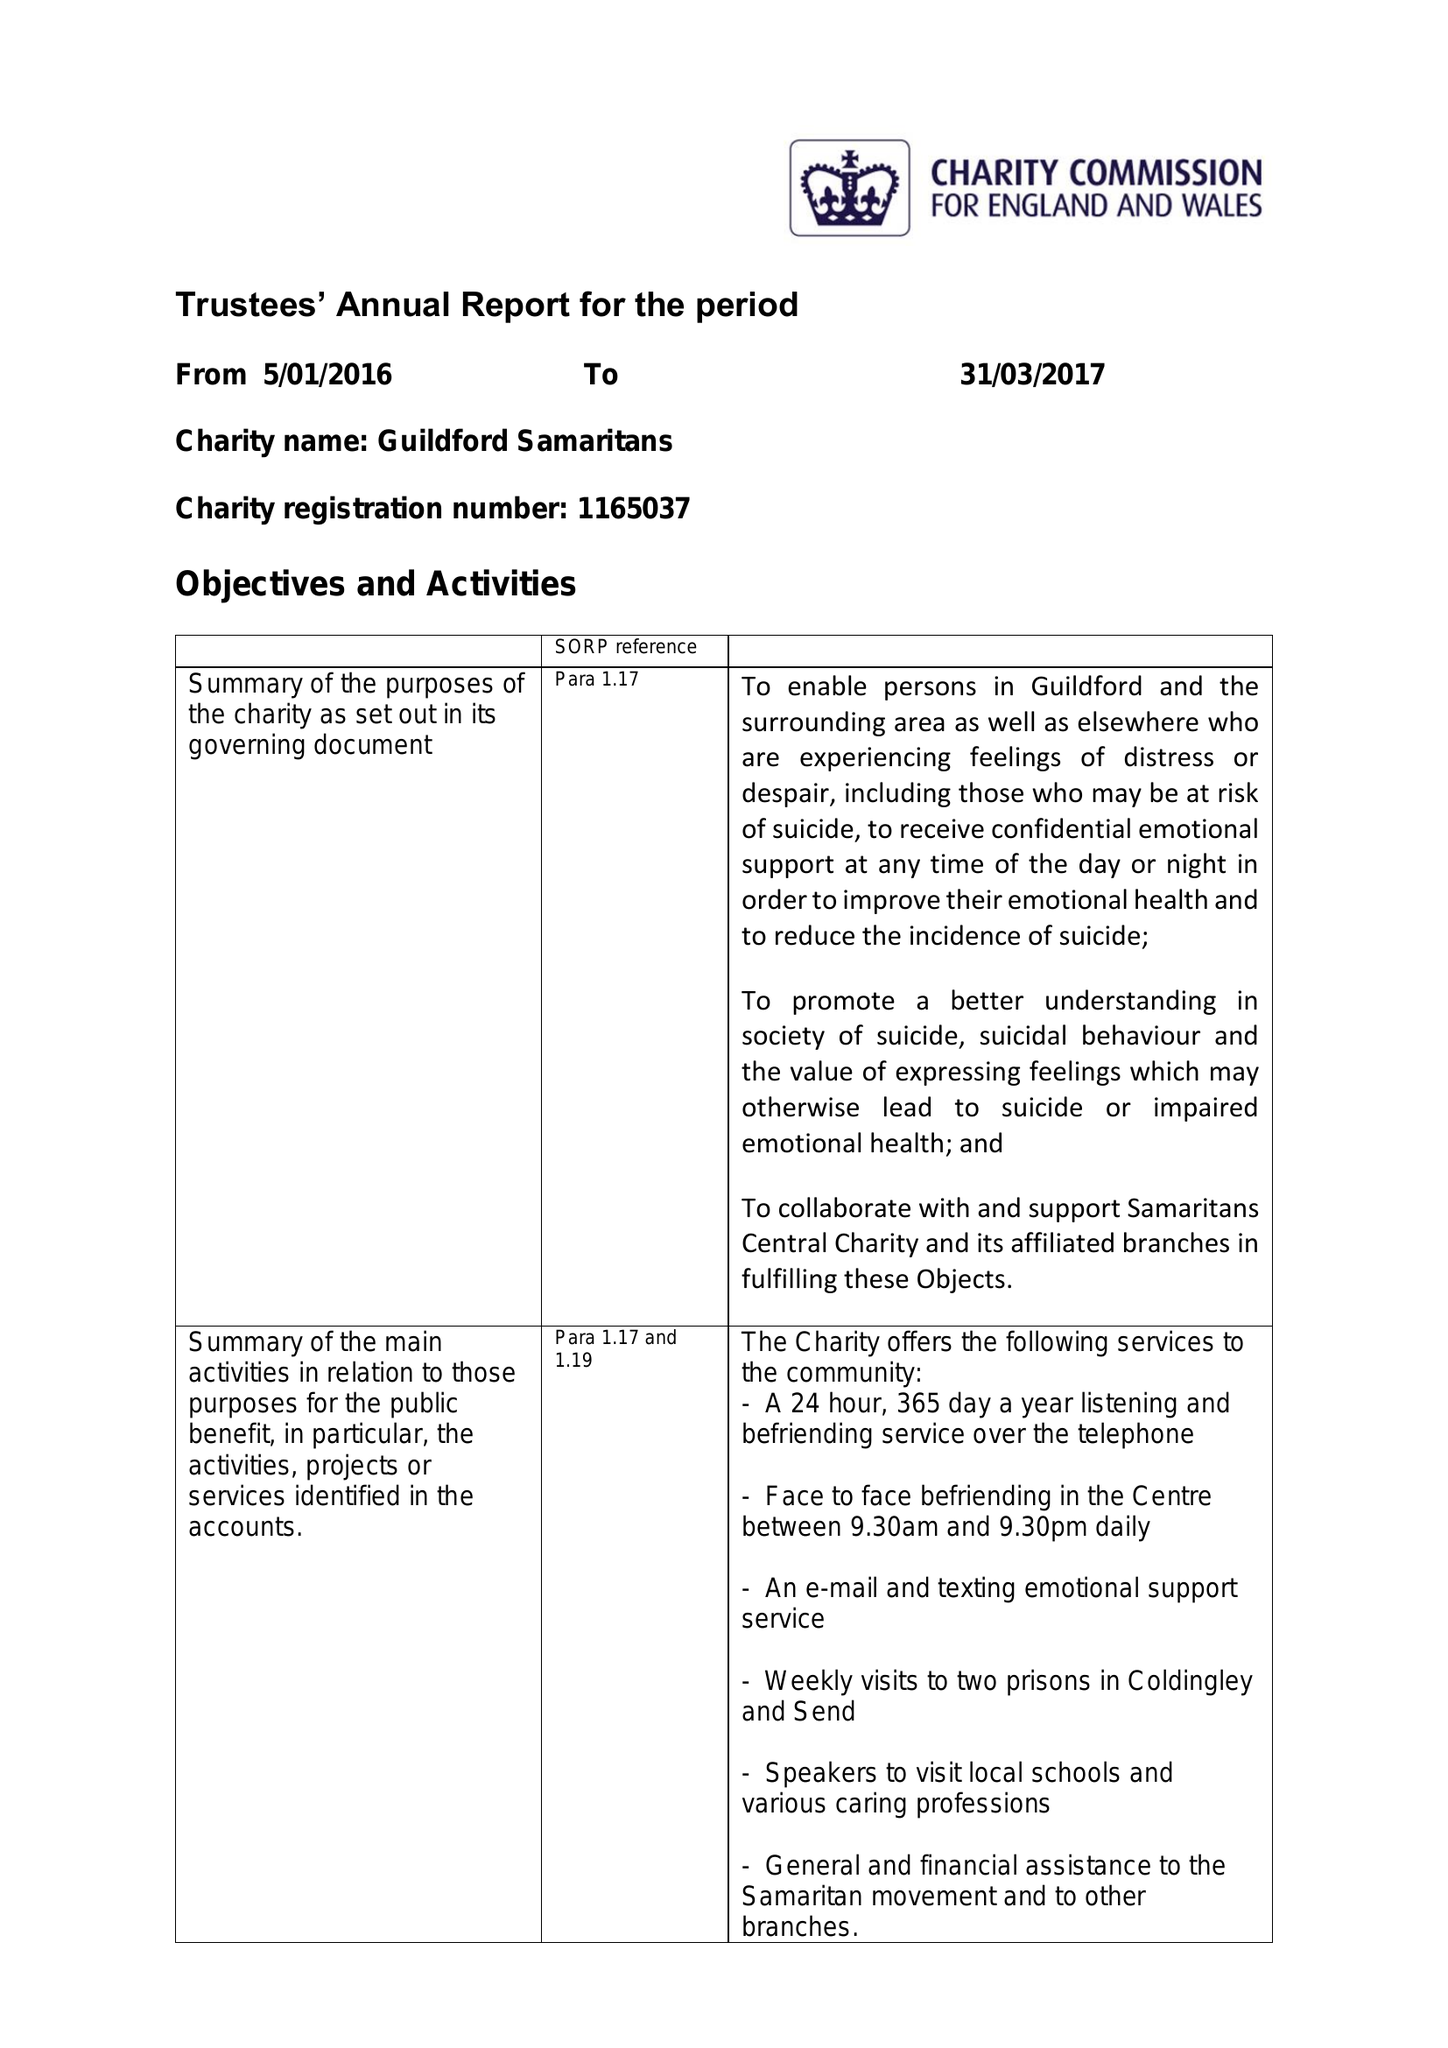What is the value for the spending_annually_in_british_pounds?
Answer the question using a single word or phrase. 78344.00 